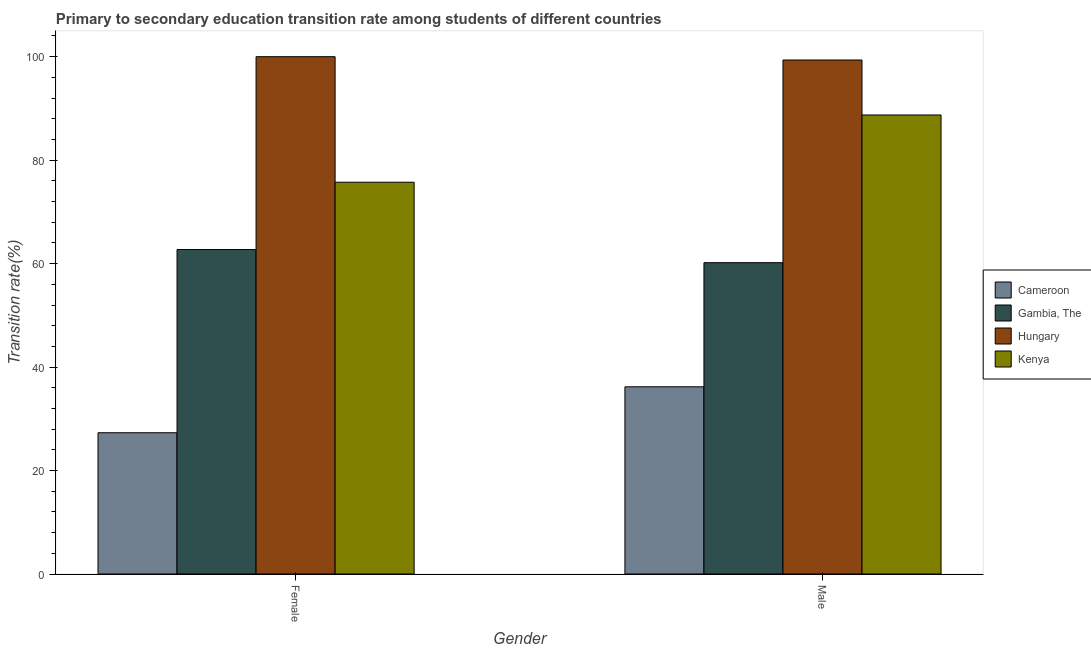How many different coloured bars are there?
Provide a succinct answer. 4. How many groups of bars are there?
Ensure brevity in your answer.  2. Are the number of bars per tick equal to the number of legend labels?
Keep it short and to the point. Yes. Are the number of bars on each tick of the X-axis equal?
Your answer should be compact. Yes. How many bars are there on the 2nd tick from the left?
Your answer should be compact. 4. What is the label of the 1st group of bars from the left?
Your response must be concise. Female. What is the transition rate among female students in Gambia, The?
Your answer should be compact. 62.72. Across all countries, what is the maximum transition rate among female students?
Your response must be concise. 100. Across all countries, what is the minimum transition rate among male students?
Provide a succinct answer. 36.19. In which country was the transition rate among male students maximum?
Give a very brief answer. Hungary. In which country was the transition rate among male students minimum?
Your answer should be compact. Cameroon. What is the total transition rate among female students in the graph?
Your response must be concise. 265.76. What is the difference between the transition rate among male students in Cameroon and that in Hungary?
Provide a short and direct response. -63.17. What is the difference between the transition rate among male students in Kenya and the transition rate among female students in Hungary?
Make the answer very short. -11.27. What is the average transition rate among female students per country?
Your answer should be compact. 66.44. What is the difference between the transition rate among male students and transition rate among female students in Kenya?
Provide a short and direct response. 13. In how many countries, is the transition rate among female students greater than 36 %?
Keep it short and to the point. 3. What is the ratio of the transition rate among female students in Cameroon to that in Hungary?
Give a very brief answer. 0.27. In how many countries, is the transition rate among female students greater than the average transition rate among female students taken over all countries?
Provide a succinct answer. 2. What does the 4th bar from the left in Female represents?
Provide a short and direct response. Kenya. What does the 2nd bar from the right in Female represents?
Provide a short and direct response. Hungary. Are all the bars in the graph horizontal?
Give a very brief answer. No. Does the graph contain grids?
Your answer should be very brief. No. How are the legend labels stacked?
Your response must be concise. Vertical. What is the title of the graph?
Keep it short and to the point. Primary to secondary education transition rate among students of different countries. What is the label or title of the Y-axis?
Ensure brevity in your answer.  Transition rate(%). What is the Transition rate(%) of Cameroon in Female?
Provide a succinct answer. 27.31. What is the Transition rate(%) in Gambia, The in Female?
Your answer should be very brief. 62.72. What is the Transition rate(%) in Kenya in Female?
Offer a terse response. 75.73. What is the Transition rate(%) in Cameroon in Male?
Your answer should be very brief. 36.19. What is the Transition rate(%) in Gambia, The in Male?
Your response must be concise. 60.18. What is the Transition rate(%) of Hungary in Male?
Ensure brevity in your answer.  99.36. What is the Transition rate(%) in Kenya in Male?
Keep it short and to the point. 88.73. Across all Gender, what is the maximum Transition rate(%) in Cameroon?
Ensure brevity in your answer.  36.19. Across all Gender, what is the maximum Transition rate(%) in Gambia, The?
Ensure brevity in your answer.  62.72. Across all Gender, what is the maximum Transition rate(%) in Kenya?
Your answer should be compact. 88.73. Across all Gender, what is the minimum Transition rate(%) of Cameroon?
Offer a terse response. 27.31. Across all Gender, what is the minimum Transition rate(%) of Gambia, The?
Your answer should be compact. 60.18. Across all Gender, what is the minimum Transition rate(%) of Hungary?
Keep it short and to the point. 99.36. Across all Gender, what is the minimum Transition rate(%) of Kenya?
Ensure brevity in your answer.  75.73. What is the total Transition rate(%) in Cameroon in the graph?
Offer a very short reply. 63.49. What is the total Transition rate(%) of Gambia, The in the graph?
Give a very brief answer. 122.9. What is the total Transition rate(%) in Hungary in the graph?
Your answer should be compact. 199.36. What is the total Transition rate(%) in Kenya in the graph?
Provide a succinct answer. 164.46. What is the difference between the Transition rate(%) of Cameroon in Female and that in Male?
Make the answer very short. -8.88. What is the difference between the Transition rate(%) in Gambia, The in Female and that in Male?
Give a very brief answer. 2.54. What is the difference between the Transition rate(%) in Hungary in Female and that in Male?
Your answer should be compact. 0.64. What is the difference between the Transition rate(%) in Kenya in Female and that in Male?
Keep it short and to the point. -13. What is the difference between the Transition rate(%) of Cameroon in Female and the Transition rate(%) of Gambia, The in Male?
Your answer should be very brief. -32.87. What is the difference between the Transition rate(%) of Cameroon in Female and the Transition rate(%) of Hungary in Male?
Make the answer very short. -72.05. What is the difference between the Transition rate(%) of Cameroon in Female and the Transition rate(%) of Kenya in Male?
Your answer should be compact. -61.43. What is the difference between the Transition rate(%) in Gambia, The in Female and the Transition rate(%) in Hungary in Male?
Your response must be concise. -36.64. What is the difference between the Transition rate(%) of Gambia, The in Female and the Transition rate(%) of Kenya in Male?
Your answer should be very brief. -26.01. What is the difference between the Transition rate(%) of Hungary in Female and the Transition rate(%) of Kenya in Male?
Provide a short and direct response. 11.27. What is the average Transition rate(%) in Cameroon per Gender?
Your response must be concise. 31.75. What is the average Transition rate(%) in Gambia, The per Gender?
Offer a terse response. 61.45. What is the average Transition rate(%) in Hungary per Gender?
Your answer should be compact. 99.68. What is the average Transition rate(%) of Kenya per Gender?
Keep it short and to the point. 82.23. What is the difference between the Transition rate(%) of Cameroon and Transition rate(%) of Gambia, The in Female?
Keep it short and to the point. -35.41. What is the difference between the Transition rate(%) in Cameroon and Transition rate(%) in Hungary in Female?
Give a very brief answer. -72.69. What is the difference between the Transition rate(%) in Cameroon and Transition rate(%) in Kenya in Female?
Your answer should be very brief. -48.43. What is the difference between the Transition rate(%) of Gambia, The and Transition rate(%) of Hungary in Female?
Provide a short and direct response. -37.28. What is the difference between the Transition rate(%) of Gambia, The and Transition rate(%) of Kenya in Female?
Your answer should be compact. -13.01. What is the difference between the Transition rate(%) in Hungary and Transition rate(%) in Kenya in Female?
Make the answer very short. 24.27. What is the difference between the Transition rate(%) in Cameroon and Transition rate(%) in Gambia, The in Male?
Provide a short and direct response. -23.99. What is the difference between the Transition rate(%) of Cameroon and Transition rate(%) of Hungary in Male?
Make the answer very short. -63.17. What is the difference between the Transition rate(%) of Cameroon and Transition rate(%) of Kenya in Male?
Offer a terse response. -52.54. What is the difference between the Transition rate(%) of Gambia, The and Transition rate(%) of Hungary in Male?
Offer a terse response. -39.18. What is the difference between the Transition rate(%) in Gambia, The and Transition rate(%) in Kenya in Male?
Your answer should be very brief. -28.55. What is the difference between the Transition rate(%) of Hungary and Transition rate(%) of Kenya in Male?
Your answer should be very brief. 10.63. What is the ratio of the Transition rate(%) in Cameroon in Female to that in Male?
Your answer should be compact. 0.75. What is the ratio of the Transition rate(%) of Gambia, The in Female to that in Male?
Make the answer very short. 1.04. What is the ratio of the Transition rate(%) in Kenya in Female to that in Male?
Offer a terse response. 0.85. What is the difference between the highest and the second highest Transition rate(%) in Cameroon?
Provide a short and direct response. 8.88. What is the difference between the highest and the second highest Transition rate(%) in Gambia, The?
Offer a terse response. 2.54. What is the difference between the highest and the second highest Transition rate(%) in Hungary?
Ensure brevity in your answer.  0.64. What is the difference between the highest and the second highest Transition rate(%) of Kenya?
Provide a short and direct response. 13. What is the difference between the highest and the lowest Transition rate(%) in Cameroon?
Your answer should be compact. 8.88. What is the difference between the highest and the lowest Transition rate(%) of Gambia, The?
Provide a short and direct response. 2.54. What is the difference between the highest and the lowest Transition rate(%) of Hungary?
Your answer should be very brief. 0.64. What is the difference between the highest and the lowest Transition rate(%) in Kenya?
Your answer should be compact. 13. 